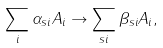<formula> <loc_0><loc_0><loc_500><loc_500>\sum _ { i } \alpha _ { s i } A _ { i } \to \sum _ { s i } \beta _ { s i } A _ { i } ,</formula> 